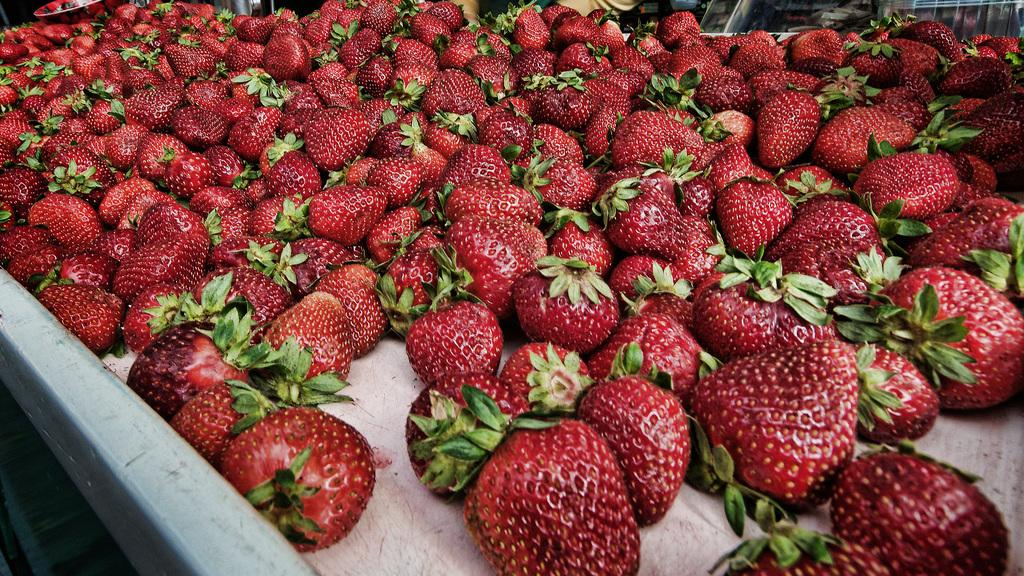What type of fruit is present in the image? There are strawberries in the image. How many strawberry plantations can be seen in the image? There are no strawberry plantations present in the image; it only features strawberries. What type of animals are interacting with the strawberries in the image? There are no animals, such as cats, present in the image; it only features strawberries. 